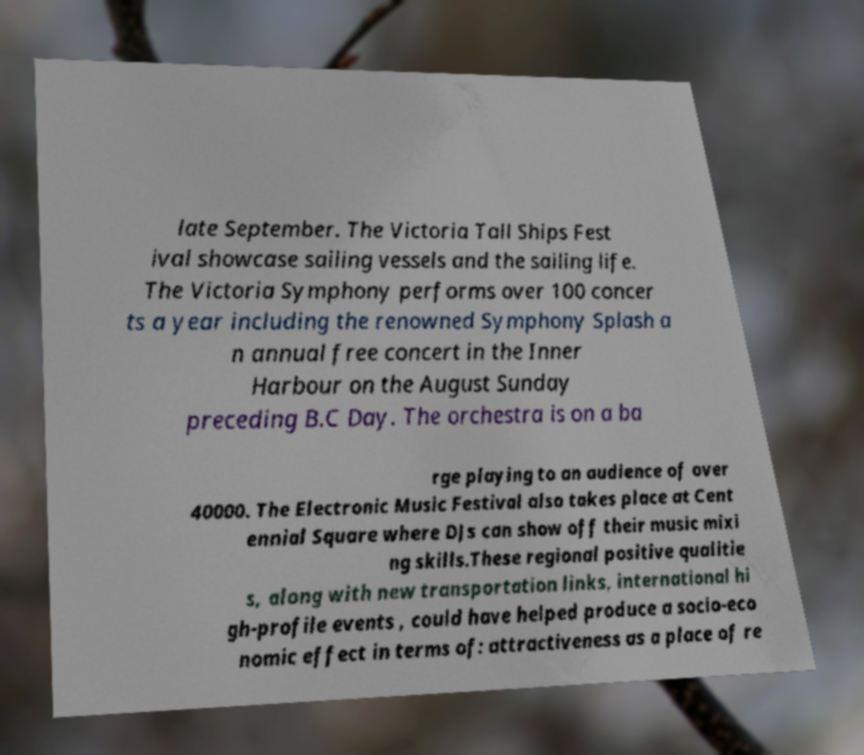Please read and relay the text visible in this image. What does it say? late September. The Victoria Tall Ships Fest ival showcase sailing vessels and the sailing life. The Victoria Symphony performs over 100 concer ts a year including the renowned Symphony Splash a n annual free concert in the Inner Harbour on the August Sunday preceding B.C Day. The orchestra is on a ba rge playing to an audience of over 40000. The Electronic Music Festival also takes place at Cent ennial Square where DJs can show off their music mixi ng skills.These regional positive qualitie s, along with new transportation links, international hi gh-profile events , could have helped produce a socio-eco nomic effect in terms of: attractiveness as a place of re 